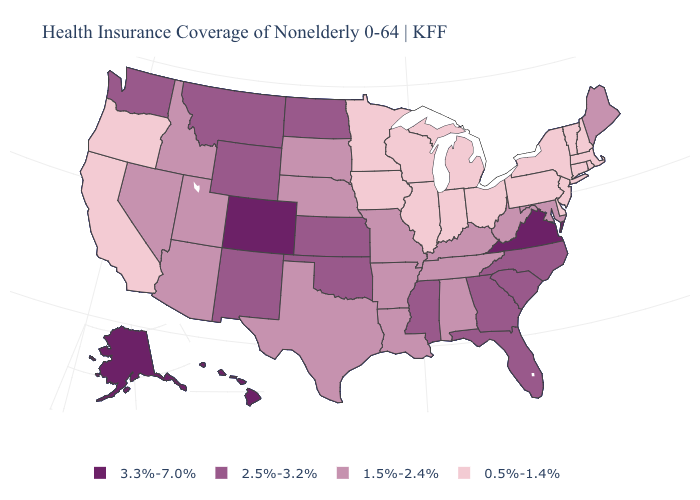Does Rhode Island have a lower value than Iowa?
Keep it brief. No. What is the lowest value in states that border Kansas?
Answer briefly. 1.5%-2.4%. What is the lowest value in the USA?
Answer briefly. 0.5%-1.4%. What is the lowest value in the MidWest?
Short answer required. 0.5%-1.4%. What is the lowest value in states that border Colorado?
Keep it brief. 1.5%-2.4%. Name the states that have a value in the range 0.5%-1.4%?
Quick response, please. California, Connecticut, Delaware, Illinois, Indiana, Iowa, Massachusetts, Michigan, Minnesota, New Hampshire, New Jersey, New York, Ohio, Oregon, Pennsylvania, Rhode Island, Vermont, Wisconsin. What is the lowest value in the MidWest?
Give a very brief answer. 0.5%-1.4%. Does Idaho have the lowest value in the USA?
Concise answer only. No. Name the states that have a value in the range 3.3%-7.0%?
Quick response, please. Alaska, Colorado, Hawaii, Virginia. Does the first symbol in the legend represent the smallest category?
Quick response, please. No. Is the legend a continuous bar?
Be succinct. No. Does New York have the lowest value in the USA?
Answer briefly. Yes. Name the states that have a value in the range 3.3%-7.0%?
Quick response, please. Alaska, Colorado, Hawaii, Virginia. What is the lowest value in the USA?
Keep it brief. 0.5%-1.4%. 